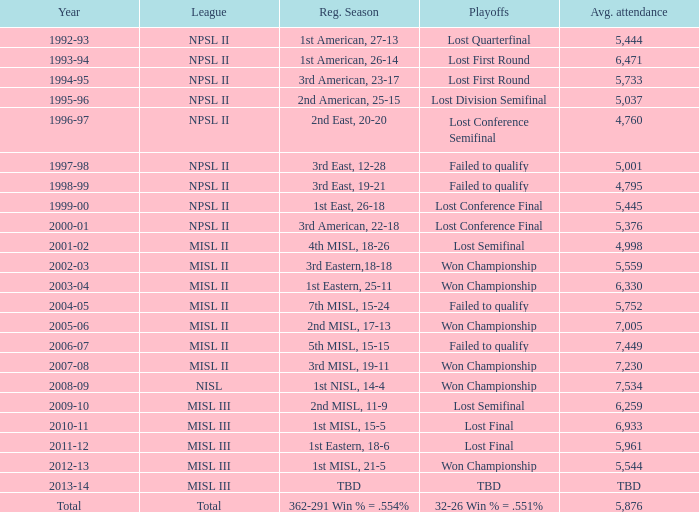In what year was the typical attendance 5,445? 1999-00. Give me the full table as a dictionary. {'header': ['Year', 'League', 'Reg. Season', 'Playoffs', 'Avg. attendance'], 'rows': [['1992-93', 'NPSL II', '1st American, 27-13', 'Lost Quarterfinal', '5,444'], ['1993-94', 'NPSL II', '1st American, 26-14', 'Lost First Round', '6,471'], ['1994-95', 'NPSL II', '3rd American, 23-17', 'Lost First Round', '5,733'], ['1995-96', 'NPSL II', '2nd American, 25-15', 'Lost Division Semifinal', '5,037'], ['1996-97', 'NPSL II', '2nd East, 20-20', 'Lost Conference Semifinal', '4,760'], ['1997-98', 'NPSL II', '3rd East, 12-28', 'Failed to qualify', '5,001'], ['1998-99', 'NPSL II', '3rd East, 19-21', 'Failed to qualify', '4,795'], ['1999-00', 'NPSL II', '1st East, 26-18', 'Lost Conference Final', '5,445'], ['2000-01', 'NPSL II', '3rd American, 22-18', 'Lost Conference Final', '5,376'], ['2001-02', 'MISL II', '4th MISL, 18-26', 'Lost Semifinal', '4,998'], ['2002-03', 'MISL II', '3rd Eastern,18-18', 'Won Championship', '5,559'], ['2003-04', 'MISL II', '1st Eastern, 25-11', 'Won Championship', '6,330'], ['2004-05', 'MISL II', '7th MISL, 15-24', 'Failed to qualify', '5,752'], ['2005-06', 'MISL II', '2nd MISL, 17-13', 'Won Championship', '7,005'], ['2006-07', 'MISL II', '5th MISL, 15-15', 'Failed to qualify', '7,449'], ['2007-08', 'MISL II', '3rd MISL, 19-11', 'Won Championship', '7,230'], ['2008-09', 'NISL', '1st NISL, 14-4', 'Won Championship', '7,534'], ['2009-10', 'MISL III', '2nd MISL, 11-9', 'Lost Semifinal', '6,259'], ['2010-11', 'MISL III', '1st MISL, 15-5', 'Lost Final', '6,933'], ['2011-12', 'MISL III', '1st Eastern, 18-6', 'Lost Final', '5,961'], ['2012-13', 'MISL III', '1st MISL, 21-5', 'Won Championship', '5,544'], ['2013-14', 'MISL III', 'TBD', 'TBD', 'TBD'], ['Total', 'Total', '362-291 Win % = .554%', '32-26 Win % = .551%', '5,876']]} 